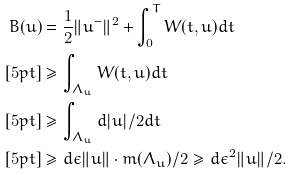Convert formula to latex. <formula><loc_0><loc_0><loc_500><loc_500>B ( u ) & = \frac { 1 } { 2 } \| u ^ { - } \| ^ { 2 } + \int _ { 0 } ^ { T } W ( t , u ) d t \\ [ 5 p t ] & \geq \int _ { \Lambda _ { u } } W ( t , u ) d t \\ [ 5 p t ] & \geq \int _ { \Lambda _ { u } } d | u | / 2 d t \\ [ 5 p t ] & \geq d \epsilon \| u \| \cdot m ( \Lambda _ { u } ) / 2 \geq d \epsilon ^ { 2 } \| u \| / 2 .</formula> 